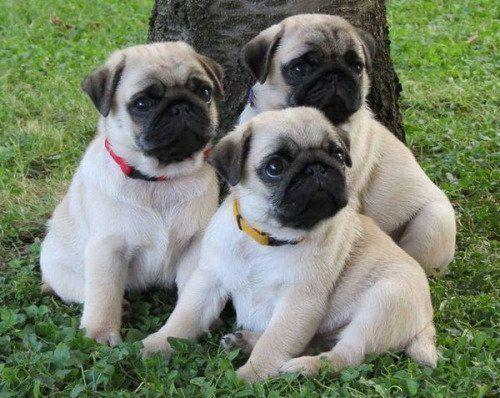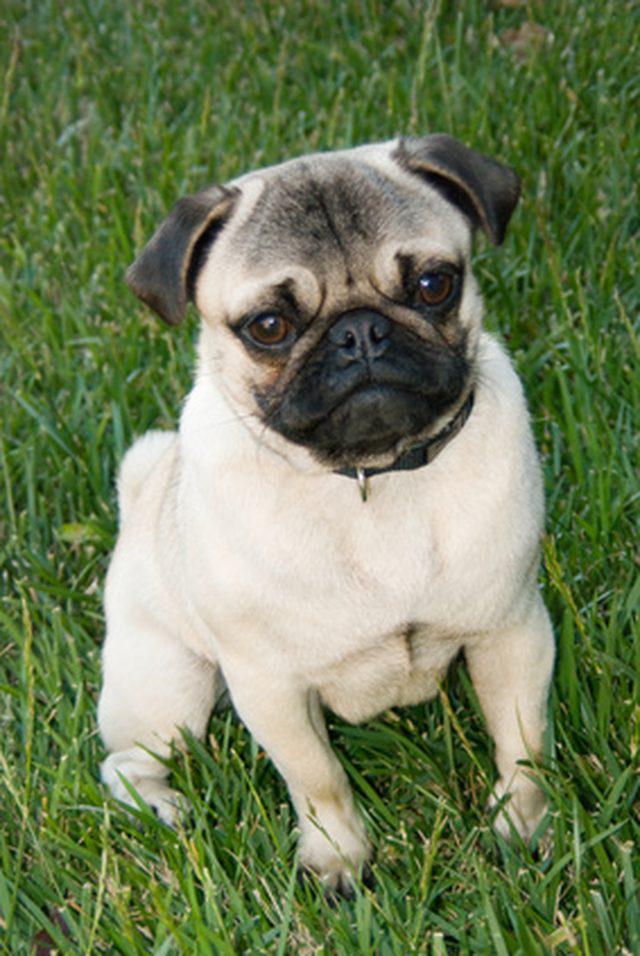The first image is the image on the left, the second image is the image on the right. For the images displayed, is the sentence "The right image contains three pug dogs." factually correct? Answer yes or no. No. 